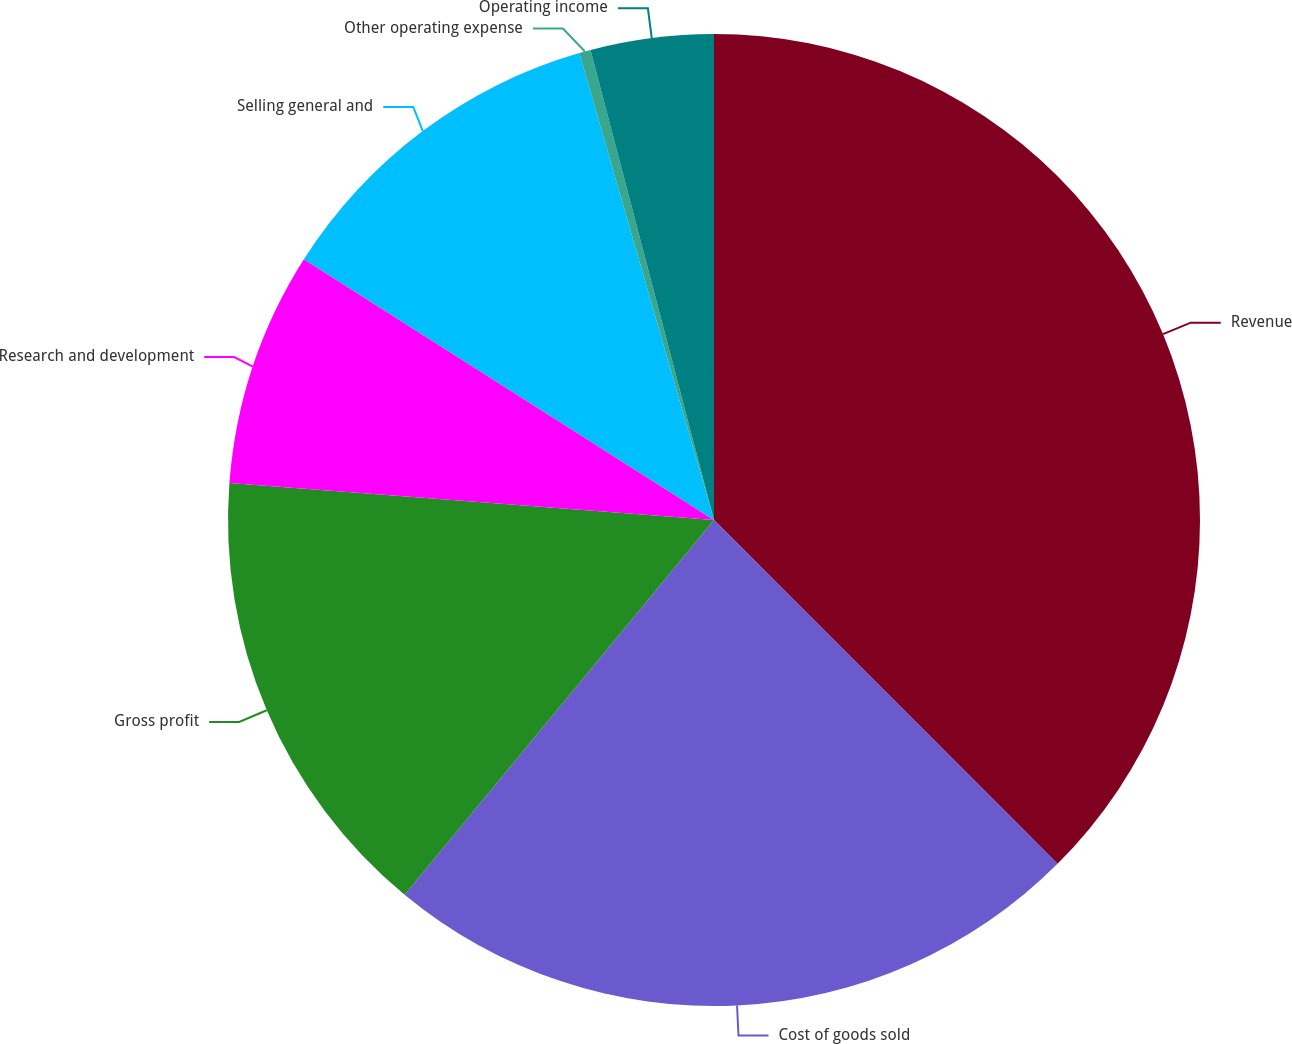<chart> <loc_0><loc_0><loc_500><loc_500><pie_chart><fcel>Revenue<fcel>Cost of goods sold<fcel>Gross profit<fcel>Research and development<fcel>Selling general and<fcel>Other operating expense<fcel>Operating income<nl><fcel>37.51%<fcel>23.48%<fcel>15.23%<fcel>7.8%<fcel>11.52%<fcel>0.38%<fcel>4.09%<nl></chart> 